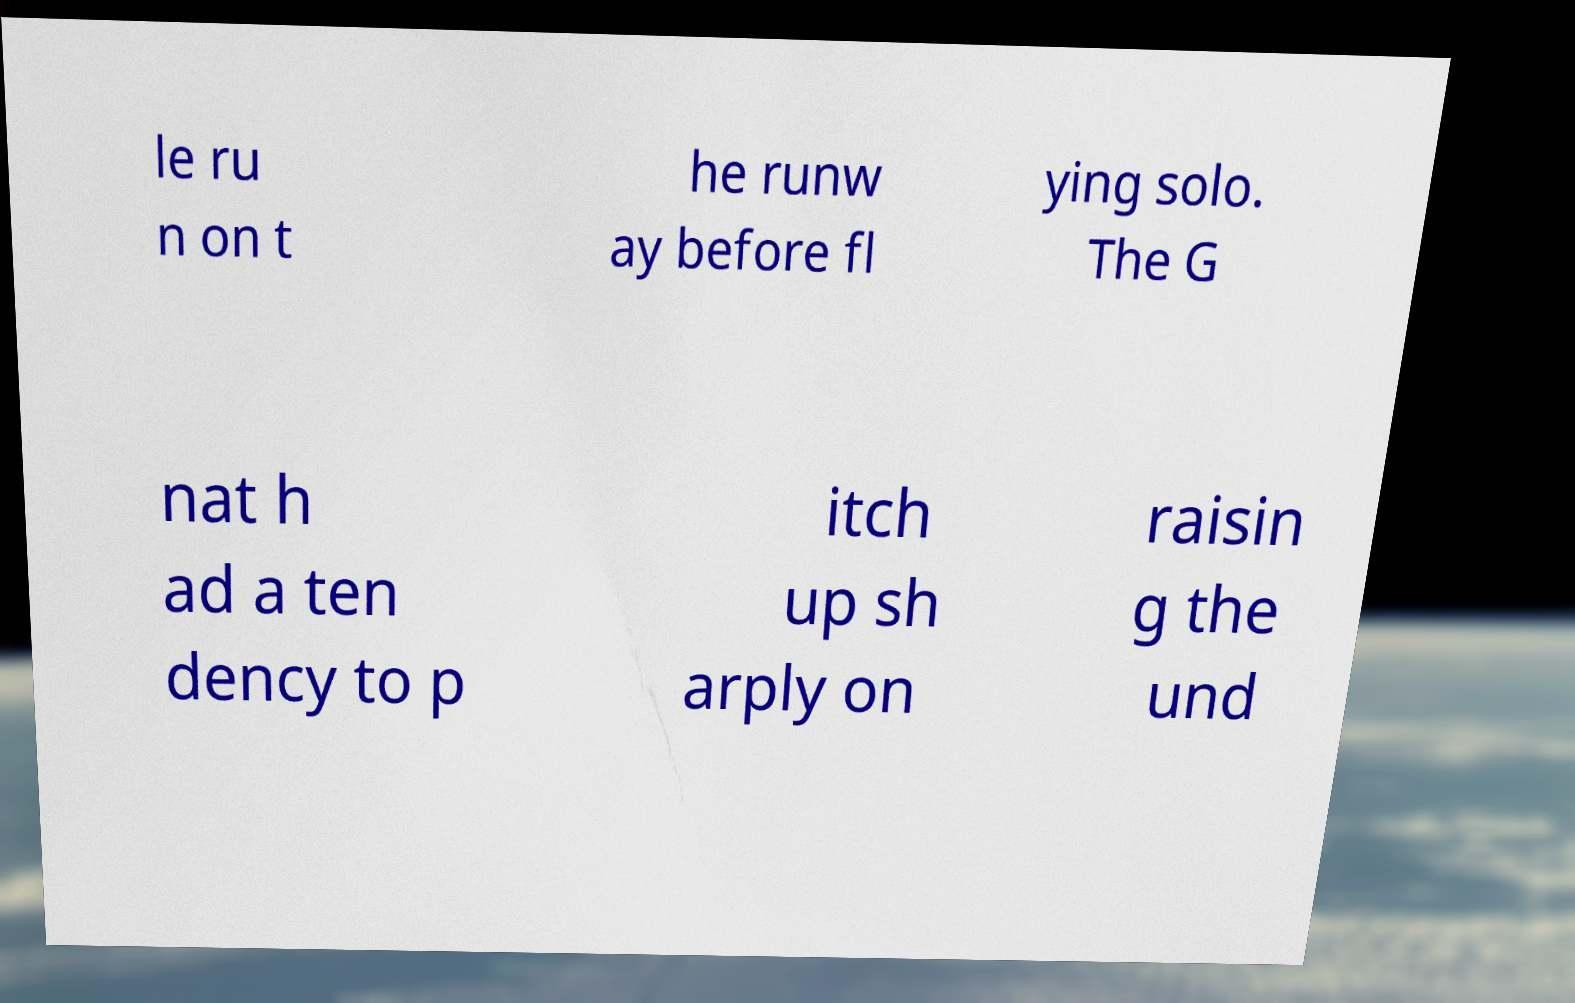There's text embedded in this image that I need extracted. Can you transcribe it verbatim? le ru n on t he runw ay before fl ying solo. The G nat h ad a ten dency to p itch up sh arply on raisin g the und 